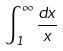<formula> <loc_0><loc_0><loc_500><loc_500>\int _ { 1 } ^ { \infty } \frac { d x } { x }</formula> 